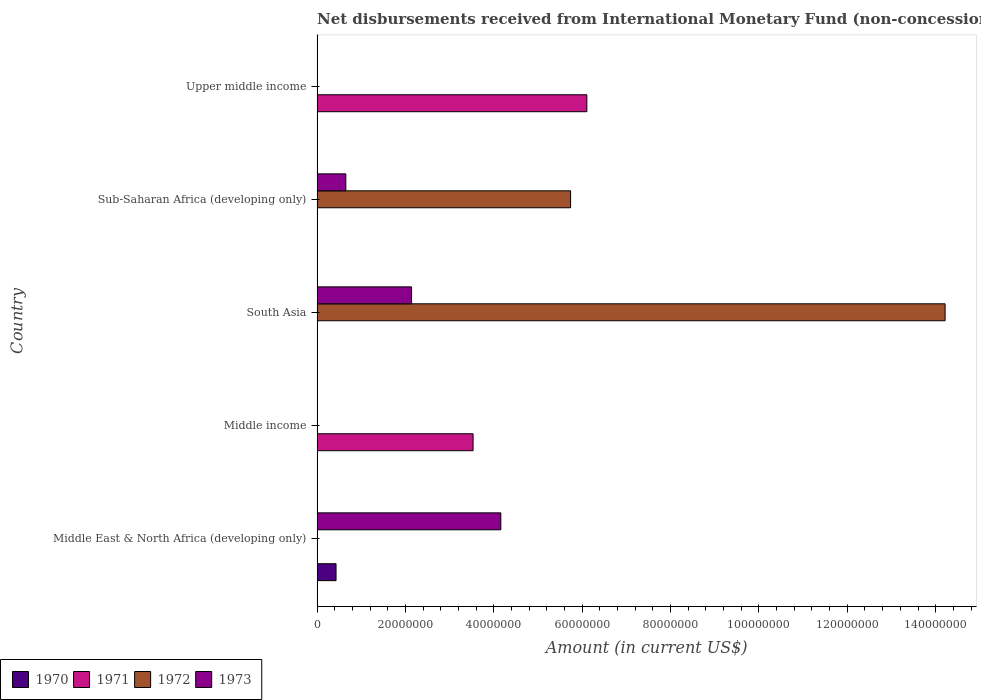How many different coloured bars are there?
Ensure brevity in your answer.  4. How many bars are there on the 3rd tick from the top?
Give a very brief answer. 2. How many bars are there on the 5th tick from the bottom?
Provide a succinct answer. 1. What is the label of the 5th group of bars from the top?
Make the answer very short. Middle East & North Africa (developing only). Across all countries, what is the maximum amount of disbursements received from International Monetary Fund in 1973?
Make the answer very short. 4.16e+07. Across all countries, what is the minimum amount of disbursements received from International Monetary Fund in 1973?
Your response must be concise. 0. In which country was the amount of disbursements received from International Monetary Fund in 1971 maximum?
Your response must be concise. Upper middle income. What is the total amount of disbursements received from International Monetary Fund in 1970 in the graph?
Keep it short and to the point. 4.30e+06. What is the difference between the amount of disbursements received from International Monetary Fund in 1973 in Middle East & North Africa (developing only) and that in South Asia?
Your answer should be compact. 2.02e+07. What is the average amount of disbursements received from International Monetary Fund in 1972 per country?
Give a very brief answer. 3.99e+07. What is the ratio of the amount of disbursements received from International Monetary Fund in 1971 in Middle income to that in Upper middle income?
Offer a very short reply. 0.58. What is the difference between the highest and the second highest amount of disbursements received from International Monetary Fund in 1973?
Ensure brevity in your answer.  2.02e+07. What is the difference between the highest and the lowest amount of disbursements received from International Monetary Fund in 1971?
Give a very brief answer. 6.11e+07. Is the sum of the amount of disbursements received from International Monetary Fund in 1971 in Middle income and Upper middle income greater than the maximum amount of disbursements received from International Monetary Fund in 1970 across all countries?
Provide a succinct answer. Yes. Is it the case that in every country, the sum of the amount of disbursements received from International Monetary Fund in 1973 and amount of disbursements received from International Monetary Fund in 1972 is greater than the amount of disbursements received from International Monetary Fund in 1971?
Ensure brevity in your answer.  No. Are all the bars in the graph horizontal?
Provide a succinct answer. Yes. Where does the legend appear in the graph?
Your answer should be very brief. Bottom left. How many legend labels are there?
Your answer should be compact. 4. What is the title of the graph?
Provide a succinct answer. Net disbursements received from International Monetary Fund (non-concessional). What is the label or title of the X-axis?
Your response must be concise. Amount (in current US$). What is the label or title of the Y-axis?
Keep it short and to the point. Country. What is the Amount (in current US$) of 1970 in Middle East & North Africa (developing only)?
Provide a succinct answer. 4.30e+06. What is the Amount (in current US$) in 1971 in Middle East & North Africa (developing only)?
Your response must be concise. 0. What is the Amount (in current US$) of 1972 in Middle East & North Africa (developing only)?
Your answer should be very brief. 0. What is the Amount (in current US$) of 1973 in Middle East & North Africa (developing only)?
Keep it short and to the point. 4.16e+07. What is the Amount (in current US$) in 1971 in Middle income?
Ensure brevity in your answer.  3.53e+07. What is the Amount (in current US$) in 1972 in Middle income?
Keep it short and to the point. 0. What is the Amount (in current US$) of 1973 in Middle income?
Your response must be concise. 0. What is the Amount (in current US$) in 1972 in South Asia?
Offer a very short reply. 1.42e+08. What is the Amount (in current US$) of 1973 in South Asia?
Your response must be concise. 2.14e+07. What is the Amount (in current US$) of 1970 in Sub-Saharan Africa (developing only)?
Offer a very short reply. 0. What is the Amount (in current US$) in 1971 in Sub-Saharan Africa (developing only)?
Keep it short and to the point. 0. What is the Amount (in current US$) of 1972 in Sub-Saharan Africa (developing only)?
Give a very brief answer. 5.74e+07. What is the Amount (in current US$) of 1973 in Sub-Saharan Africa (developing only)?
Provide a short and direct response. 6.51e+06. What is the Amount (in current US$) of 1971 in Upper middle income?
Offer a very short reply. 6.11e+07. What is the Amount (in current US$) of 1972 in Upper middle income?
Ensure brevity in your answer.  0. What is the Amount (in current US$) in 1973 in Upper middle income?
Provide a succinct answer. 0. Across all countries, what is the maximum Amount (in current US$) in 1970?
Provide a succinct answer. 4.30e+06. Across all countries, what is the maximum Amount (in current US$) of 1971?
Ensure brevity in your answer.  6.11e+07. Across all countries, what is the maximum Amount (in current US$) in 1972?
Provide a succinct answer. 1.42e+08. Across all countries, what is the maximum Amount (in current US$) in 1973?
Keep it short and to the point. 4.16e+07. Across all countries, what is the minimum Amount (in current US$) of 1970?
Provide a short and direct response. 0. Across all countries, what is the minimum Amount (in current US$) of 1971?
Provide a succinct answer. 0. Across all countries, what is the minimum Amount (in current US$) of 1972?
Provide a succinct answer. 0. Across all countries, what is the minimum Amount (in current US$) of 1973?
Your response must be concise. 0. What is the total Amount (in current US$) in 1970 in the graph?
Keep it short and to the point. 4.30e+06. What is the total Amount (in current US$) of 1971 in the graph?
Offer a terse response. 9.64e+07. What is the total Amount (in current US$) in 1972 in the graph?
Provide a succinct answer. 2.00e+08. What is the total Amount (in current US$) in 1973 in the graph?
Make the answer very short. 6.95e+07. What is the difference between the Amount (in current US$) in 1973 in Middle East & North Africa (developing only) and that in South Asia?
Provide a short and direct response. 2.02e+07. What is the difference between the Amount (in current US$) of 1973 in Middle East & North Africa (developing only) and that in Sub-Saharan Africa (developing only)?
Offer a very short reply. 3.51e+07. What is the difference between the Amount (in current US$) of 1971 in Middle income and that in Upper middle income?
Keep it short and to the point. -2.57e+07. What is the difference between the Amount (in current US$) in 1972 in South Asia and that in Sub-Saharan Africa (developing only)?
Ensure brevity in your answer.  8.48e+07. What is the difference between the Amount (in current US$) in 1973 in South Asia and that in Sub-Saharan Africa (developing only)?
Offer a very short reply. 1.49e+07. What is the difference between the Amount (in current US$) in 1970 in Middle East & North Africa (developing only) and the Amount (in current US$) in 1971 in Middle income?
Keep it short and to the point. -3.10e+07. What is the difference between the Amount (in current US$) in 1970 in Middle East & North Africa (developing only) and the Amount (in current US$) in 1972 in South Asia?
Keep it short and to the point. -1.38e+08. What is the difference between the Amount (in current US$) in 1970 in Middle East & North Africa (developing only) and the Amount (in current US$) in 1973 in South Asia?
Give a very brief answer. -1.71e+07. What is the difference between the Amount (in current US$) of 1970 in Middle East & North Africa (developing only) and the Amount (in current US$) of 1972 in Sub-Saharan Africa (developing only)?
Provide a succinct answer. -5.31e+07. What is the difference between the Amount (in current US$) in 1970 in Middle East & North Africa (developing only) and the Amount (in current US$) in 1973 in Sub-Saharan Africa (developing only)?
Ensure brevity in your answer.  -2.21e+06. What is the difference between the Amount (in current US$) in 1970 in Middle East & North Africa (developing only) and the Amount (in current US$) in 1971 in Upper middle income?
Provide a short and direct response. -5.68e+07. What is the difference between the Amount (in current US$) in 1971 in Middle income and the Amount (in current US$) in 1972 in South Asia?
Make the answer very short. -1.07e+08. What is the difference between the Amount (in current US$) in 1971 in Middle income and the Amount (in current US$) in 1973 in South Asia?
Your response must be concise. 1.39e+07. What is the difference between the Amount (in current US$) of 1971 in Middle income and the Amount (in current US$) of 1972 in Sub-Saharan Africa (developing only)?
Make the answer very short. -2.21e+07. What is the difference between the Amount (in current US$) in 1971 in Middle income and the Amount (in current US$) in 1973 in Sub-Saharan Africa (developing only)?
Provide a short and direct response. 2.88e+07. What is the difference between the Amount (in current US$) in 1972 in South Asia and the Amount (in current US$) in 1973 in Sub-Saharan Africa (developing only)?
Provide a succinct answer. 1.36e+08. What is the average Amount (in current US$) of 1970 per country?
Your answer should be very brief. 8.60e+05. What is the average Amount (in current US$) of 1971 per country?
Keep it short and to the point. 1.93e+07. What is the average Amount (in current US$) in 1972 per country?
Your answer should be compact. 3.99e+07. What is the average Amount (in current US$) of 1973 per country?
Offer a terse response. 1.39e+07. What is the difference between the Amount (in current US$) of 1970 and Amount (in current US$) of 1973 in Middle East & North Africa (developing only)?
Make the answer very short. -3.73e+07. What is the difference between the Amount (in current US$) in 1972 and Amount (in current US$) in 1973 in South Asia?
Offer a very short reply. 1.21e+08. What is the difference between the Amount (in current US$) of 1972 and Amount (in current US$) of 1973 in Sub-Saharan Africa (developing only)?
Your answer should be compact. 5.09e+07. What is the ratio of the Amount (in current US$) in 1973 in Middle East & North Africa (developing only) to that in South Asia?
Your answer should be compact. 1.94. What is the ratio of the Amount (in current US$) in 1973 in Middle East & North Africa (developing only) to that in Sub-Saharan Africa (developing only)?
Provide a succinct answer. 6.39. What is the ratio of the Amount (in current US$) of 1971 in Middle income to that in Upper middle income?
Make the answer very short. 0.58. What is the ratio of the Amount (in current US$) of 1972 in South Asia to that in Sub-Saharan Africa (developing only)?
Provide a short and direct response. 2.48. What is the ratio of the Amount (in current US$) in 1973 in South Asia to that in Sub-Saharan Africa (developing only)?
Make the answer very short. 3.29. What is the difference between the highest and the second highest Amount (in current US$) in 1973?
Offer a terse response. 2.02e+07. What is the difference between the highest and the lowest Amount (in current US$) of 1970?
Your response must be concise. 4.30e+06. What is the difference between the highest and the lowest Amount (in current US$) in 1971?
Ensure brevity in your answer.  6.11e+07. What is the difference between the highest and the lowest Amount (in current US$) of 1972?
Your answer should be very brief. 1.42e+08. What is the difference between the highest and the lowest Amount (in current US$) in 1973?
Keep it short and to the point. 4.16e+07. 